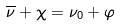<formula> <loc_0><loc_0><loc_500><loc_500>\overline { \nu } + \chi = \nu _ { 0 } + \varphi</formula> 